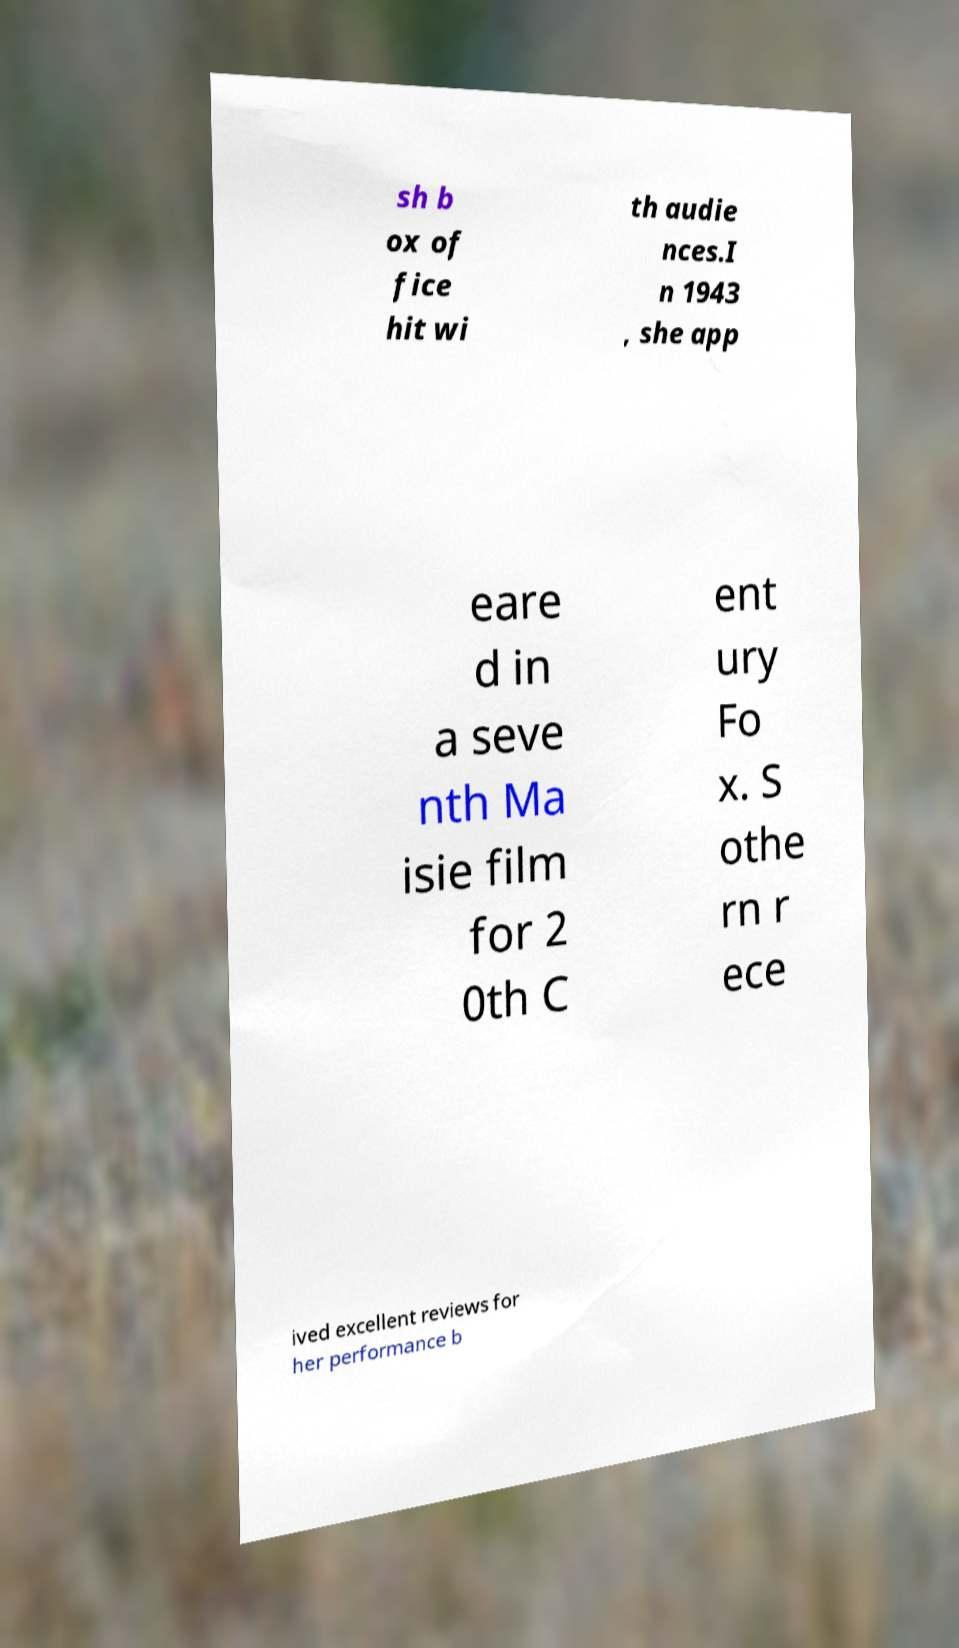I need the written content from this picture converted into text. Can you do that? sh b ox of fice hit wi th audie nces.I n 1943 , she app eare d in a seve nth Ma isie film for 2 0th C ent ury Fo x. S othe rn r ece ived excellent reviews for her performance b 